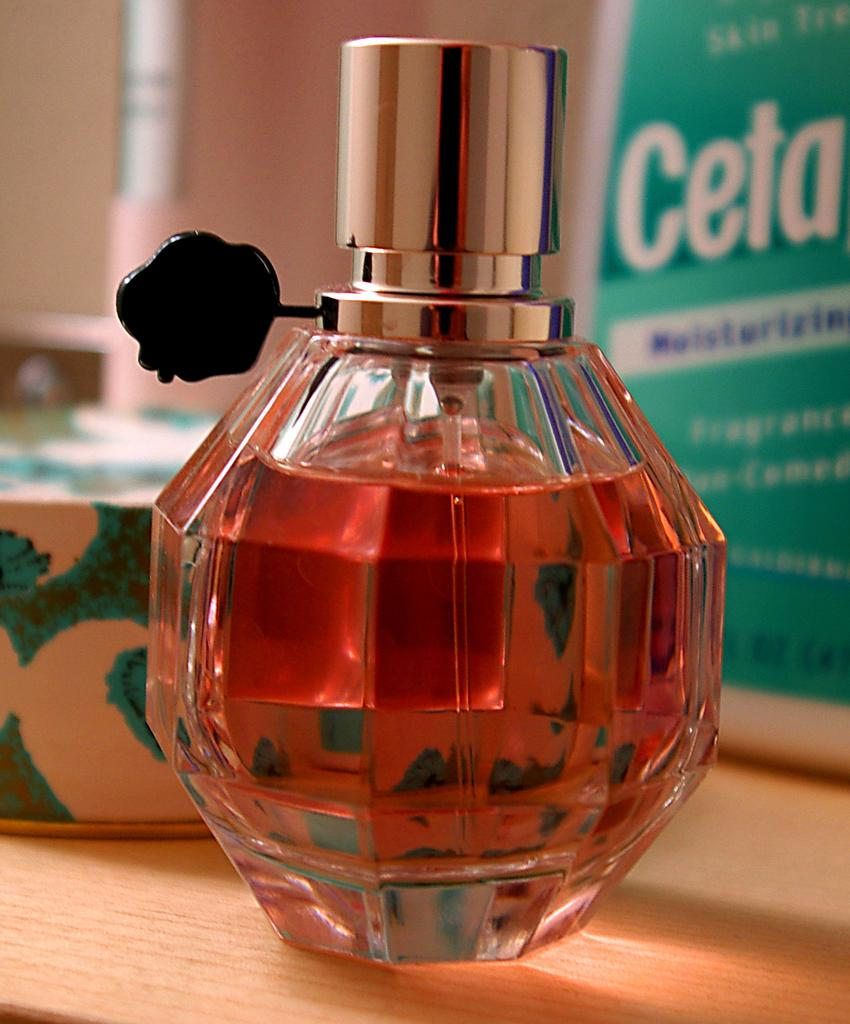<image>
Write a terse but informative summary of the picture. A bottle of perfume in front of a bottle of Ceta. 